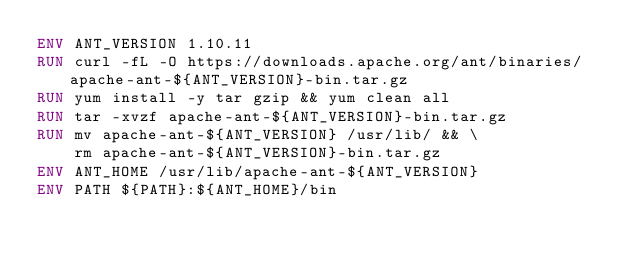Convert code to text. <code><loc_0><loc_0><loc_500><loc_500><_Dockerfile_>ENV ANT_VERSION 1.10.11
RUN curl -fL -O https://downloads.apache.org/ant/binaries/apache-ant-${ANT_VERSION}-bin.tar.gz
RUN yum install -y tar gzip && yum clean all
RUN tar -xvzf apache-ant-${ANT_VERSION}-bin.tar.gz
RUN mv apache-ant-${ANT_VERSION} /usr/lib/ && \
    rm apache-ant-${ANT_VERSION}-bin.tar.gz
ENV ANT_HOME /usr/lib/apache-ant-${ANT_VERSION}
ENV PATH ${PATH}:${ANT_HOME}/bin</code> 